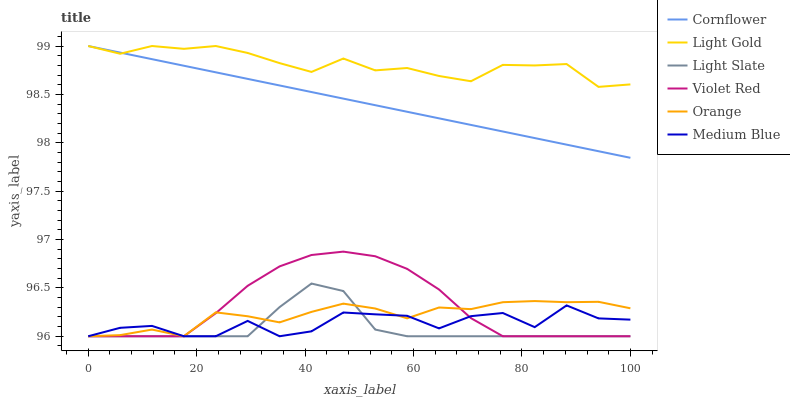Does Light Slate have the minimum area under the curve?
Answer yes or no. Yes. Does Light Gold have the maximum area under the curve?
Answer yes or no. Yes. Does Violet Red have the minimum area under the curve?
Answer yes or no. No. Does Violet Red have the maximum area under the curve?
Answer yes or no. No. Is Cornflower the smoothest?
Answer yes or no. Yes. Is Medium Blue the roughest?
Answer yes or no. Yes. Is Violet Red the smoothest?
Answer yes or no. No. Is Violet Red the roughest?
Answer yes or no. No. Does Light Gold have the lowest value?
Answer yes or no. No. Does Light Gold have the highest value?
Answer yes or no. Yes. Does Violet Red have the highest value?
Answer yes or no. No. Is Light Slate less than Cornflower?
Answer yes or no. Yes. Is Light Gold greater than Light Slate?
Answer yes or no. Yes. Does Medium Blue intersect Light Slate?
Answer yes or no. Yes. Is Medium Blue less than Light Slate?
Answer yes or no. No. Is Medium Blue greater than Light Slate?
Answer yes or no. No. Does Light Slate intersect Cornflower?
Answer yes or no. No. 